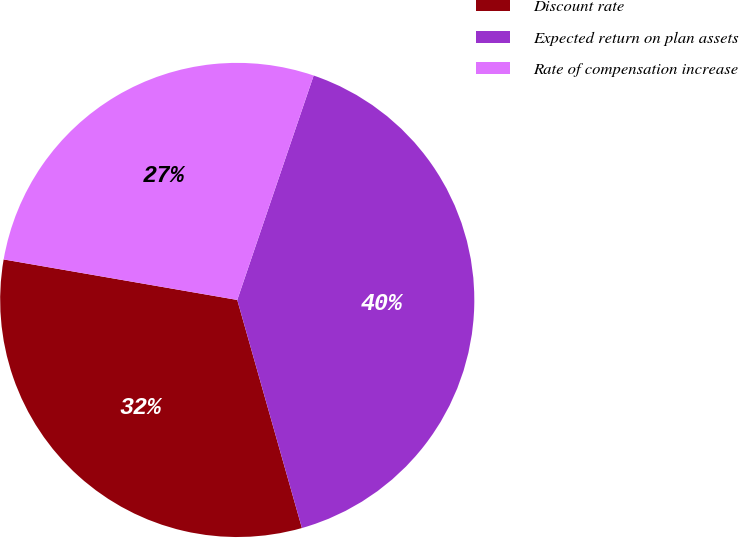Convert chart to OTSL. <chart><loc_0><loc_0><loc_500><loc_500><pie_chart><fcel>Discount rate<fcel>Expected return on plan assets<fcel>Rate of compensation increase<nl><fcel>32.13%<fcel>40.38%<fcel>27.49%<nl></chart> 